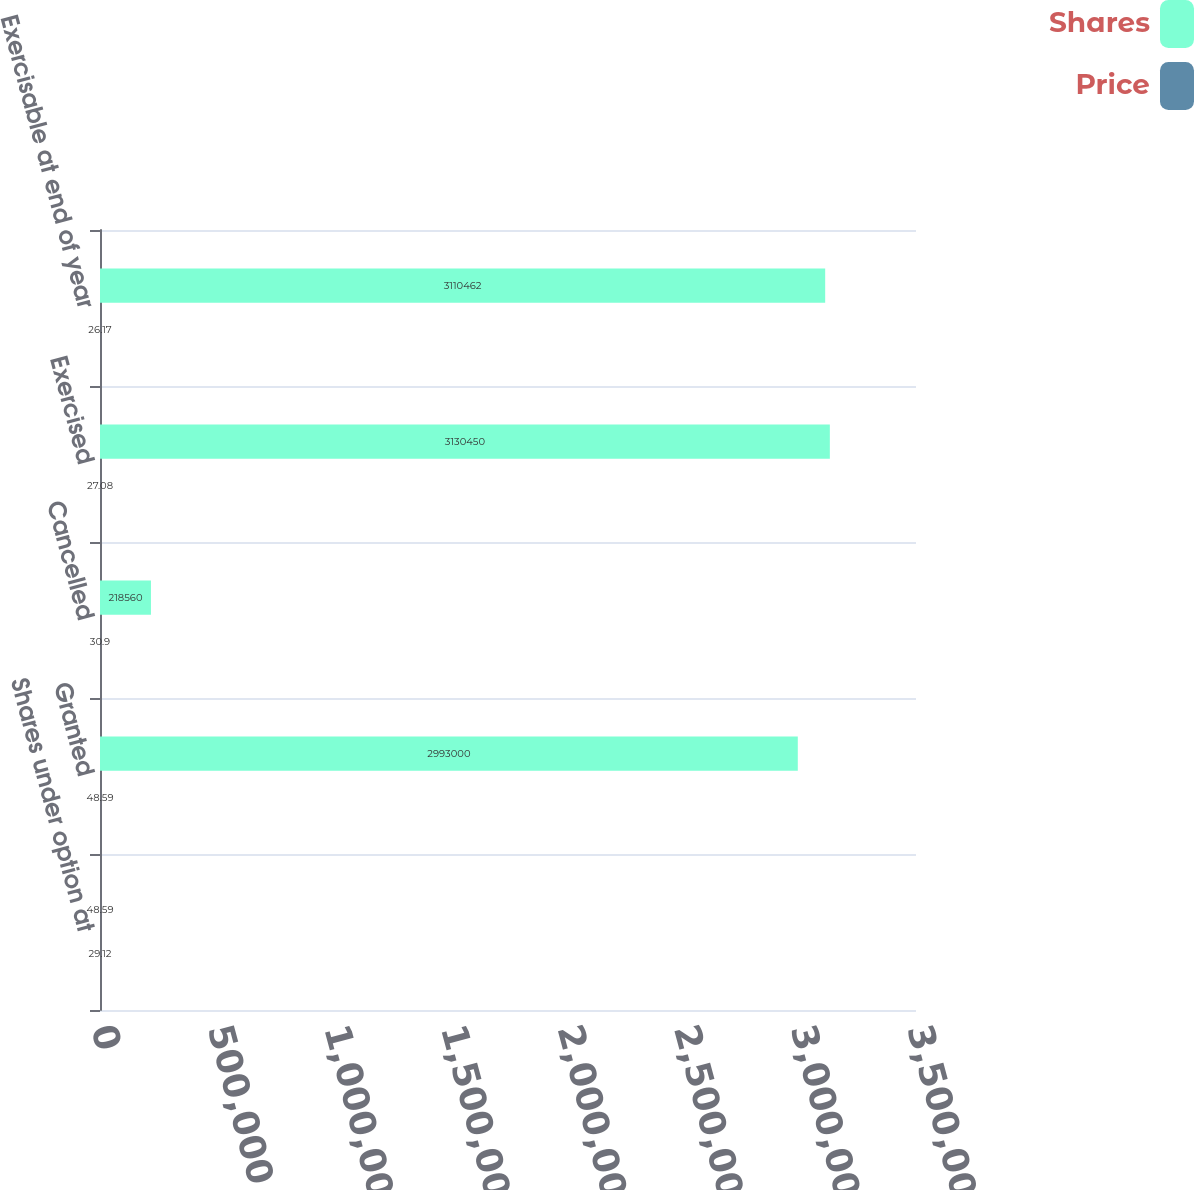Convert chart to OTSL. <chart><loc_0><loc_0><loc_500><loc_500><stacked_bar_chart><ecel><fcel>Shares under option at<fcel>Granted<fcel>Cancelled<fcel>Exercised<fcel>Exercisable at end of year<nl><fcel>Shares<fcel>48.59<fcel>2.993e+06<fcel>218560<fcel>3.13045e+06<fcel>3.11046e+06<nl><fcel>Price<fcel>29.12<fcel>48.59<fcel>30.9<fcel>27.08<fcel>26.17<nl></chart> 